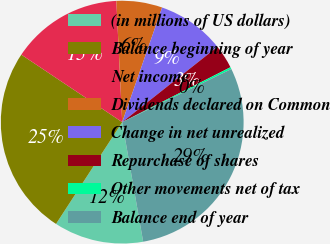Convert chart to OTSL. <chart><loc_0><loc_0><loc_500><loc_500><pie_chart><fcel>(in millions of US dollars)<fcel>Balance beginning of year<fcel>Net income<fcel>Dividends declared on Common<fcel>Change in net unrealized<fcel>Repurchase of shares<fcel>Other movements net of tax<fcel>Balance end of year<nl><fcel>11.94%<fcel>25.21%<fcel>14.85%<fcel>6.1%<fcel>9.02%<fcel>3.18%<fcel>0.26%<fcel>29.45%<nl></chart> 